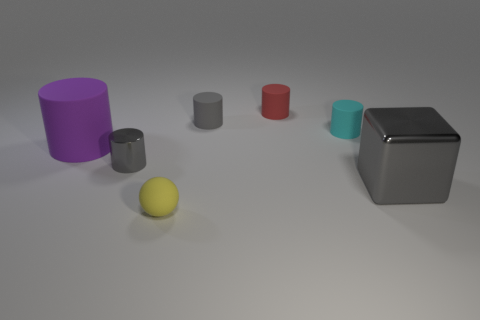Subtract all small red cylinders. How many cylinders are left? 4 Subtract all red cylinders. How many cylinders are left? 4 Subtract 1 cylinders. How many cylinders are left? 4 Subtract all green cylinders. Subtract all green spheres. How many cylinders are left? 5 Add 1 purple matte cylinders. How many objects exist? 8 Subtract all cylinders. How many objects are left? 2 Add 4 tiny yellow things. How many tiny yellow things are left? 5 Add 1 big rubber spheres. How many big rubber spheres exist? 1 Subtract 0 purple cubes. How many objects are left? 7 Subtract all tiny gray blocks. Subtract all gray rubber cylinders. How many objects are left? 6 